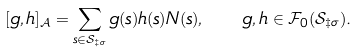<formula> <loc_0><loc_0><loc_500><loc_500>[ g , h ] _ { \mathcal { A } } = \sum _ { s \in \mathcal { S } _ { \ddagger \sigma } } g ( s ) h ( s ) N ( s ) , \quad g , h \in \mathcal { F } _ { 0 } ( \mathcal { S } _ { \ddagger \sigma } ) .</formula> 